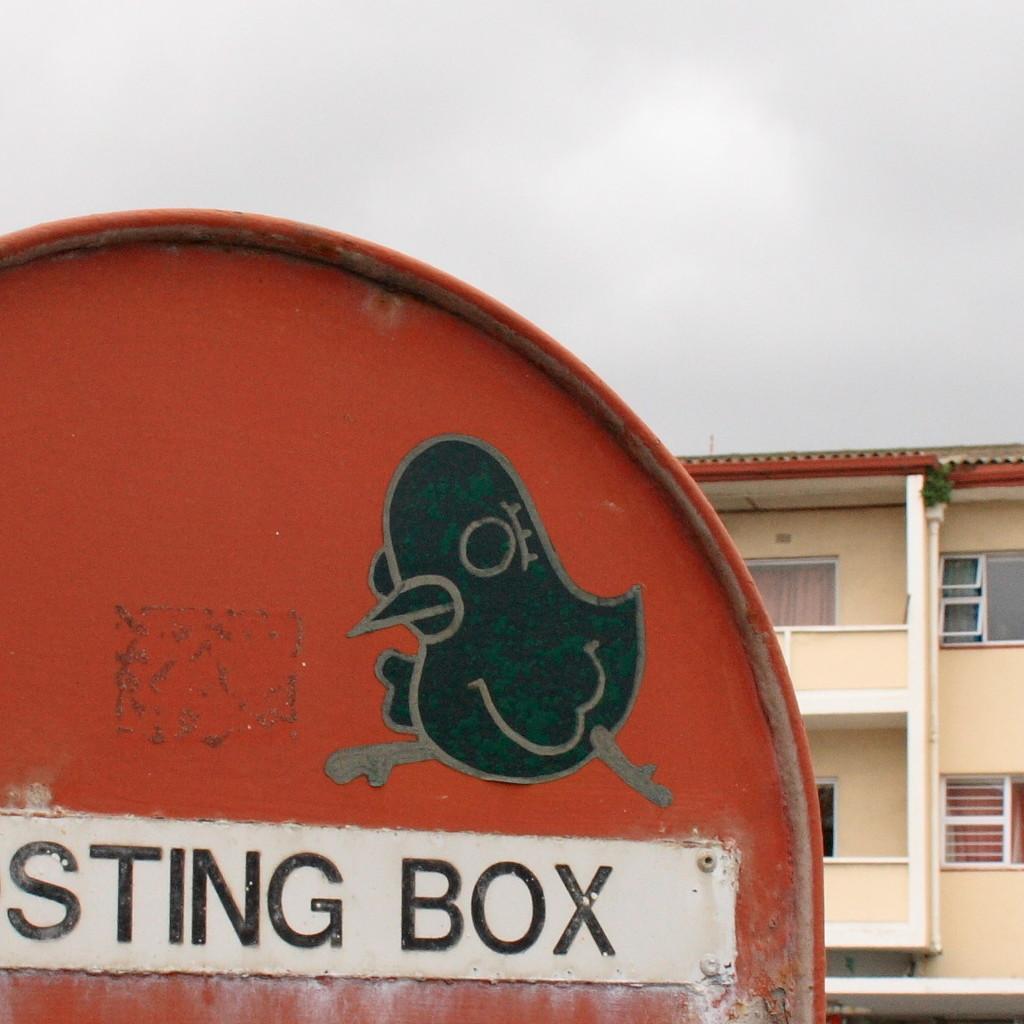In one or two sentences, can you explain what this image depicts? Here we can see a board and a building. In the background there is sky. 